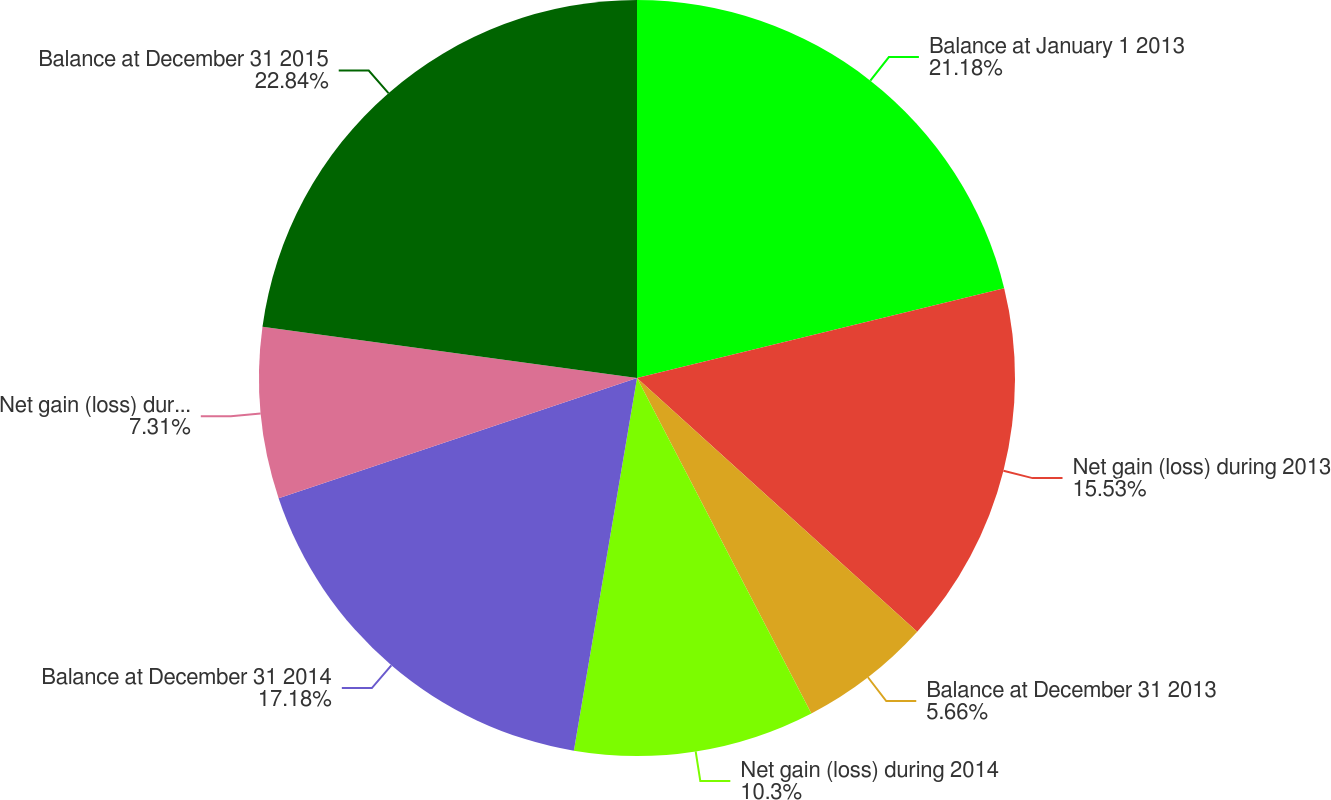<chart> <loc_0><loc_0><loc_500><loc_500><pie_chart><fcel>Balance at January 1 2013<fcel>Net gain (loss) during 2013<fcel>Balance at December 31 2013<fcel>Net gain (loss) during 2014<fcel>Balance at December 31 2014<fcel>Net gain (loss) during 2015<fcel>Balance at December 31 2015<nl><fcel>21.18%<fcel>15.53%<fcel>5.66%<fcel>10.3%<fcel>17.18%<fcel>7.31%<fcel>22.84%<nl></chart> 